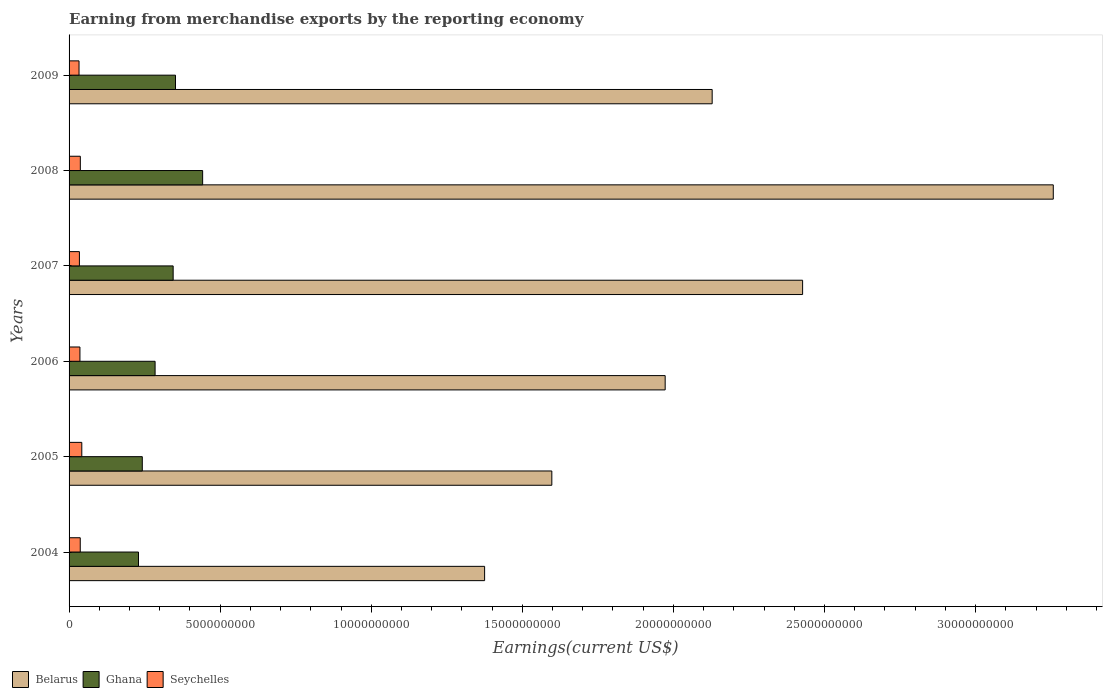Are the number of bars per tick equal to the number of legend labels?
Your response must be concise. Yes. Are the number of bars on each tick of the Y-axis equal?
Your answer should be very brief. Yes. What is the label of the 3rd group of bars from the top?
Your response must be concise. 2007. In how many cases, is the number of bars for a given year not equal to the number of legend labels?
Offer a very short reply. 0. What is the amount earned from merchandise exports in Ghana in 2004?
Your answer should be very brief. 2.30e+09. Across all years, what is the maximum amount earned from merchandise exports in Belarus?
Offer a terse response. 3.26e+1. Across all years, what is the minimum amount earned from merchandise exports in Seychelles?
Keep it short and to the point. 3.30e+08. What is the total amount earned from merchandise exports in Ghana in the graph?
Your response must be concise. 1.90e+1. What is the difference between the amount earned from merchandise exports in Belarus in 2004 and that in 2008?
Make the answer very short. -1.88e+1. What is the difference between the amount earned from merchandise exports in Ghana in 2006 and the amount earned from merchandise exports in Seychelles in 2009?
Your response must be concise. 2.52e+09. What is the average amount earned from merchandise exports in Ghana per year?
Your response must be concise. 3.16e+09. In the year 2007, what is the difference between the amount earned from merchandise exports in Seychelles and amount earned from merchandise exports in Belarus?
Provide a succinct answer. -2.39e+1. In how many years, is the amount earned from merchandise exports in Belarus greater than 3000000000 US$?
Provide a short and direct response. 6. What is the ratio of the amount earned from merchandise exports in Belarus in 2004 to that in 2005?
Your answer should be very brief. 0.86. Is the amount earned from merchandise exports in Seychelles in 2006 less than that in 2007?
Make the answer very short. No. What is the difference between the highest and the second highest amount earned from merchandise exports in Seychelles?
Your response must be concise. 4.87e+07. What is the difference between the highest and the lowest amount earned from merchandise exports in Seychelles?
Your answer should be very brief. 9.14e+07. Is the sum of the amount earned from merchandise exports in Ghana in 2005 and 2008 greater than the maximum amount earned from merchandise exports in Belarus across all years?
Provide a short and direct response. No. What does the 2nd bar from the top in 2008 represents?
Your response must be concise. Ghana. What does the 1st bar from the bottom in 2005 represents?
Offer a terse response. Belarus. How many years are there in the graph?
Make the answer very short. 6. What is the difference between two consecutive major ticks on the X-axis?
Make the answer very short. 5.00e+09. Does the graph contain any zero values?
Your answer should be compact. No. Does the graph contain grids?
Offer a very short reply. No. Where does the legend appear in the graph?
Provide a succinct answer. Bottom left. What is the title of the graph?
Give a very brief answer. Earning from merchandise exports by the reporting economy. What is the label or title of the X-axis?
Your answer should be compact. Earnings(current US$). What is the label or title of the Y-axis?
Provide a succinct answer. Years. What is the Earnings(current US$) of Belarus in 2004?
Offer a very short reply. 1.38e+1. What is the Earnings(current US$) of Ghana in 2004?
Provide a succinct answer. 2.30e+09. What is the Earnings(current US$) of Seychelles in 2004?
Your response must be concise. 3.70e+08. What is the Earnings(current US$) of Belarus in 2005?
Give a very brief answer. 1.60e+1. What is the Earnings(current US$) in Ghana in 2005?
Your answer should be very brief. 2.42e+09. What is the Earnings(current US$) of Seychelles in 2005?
Your answer should be very brief. 4.21e+08. What is the Earnings(current US$) in Belarus in 2006?
Provide a succinct answer. 1.97e+1. What is the Earnings(current US$) in Ghana in 2006?
Provide a short and direct response. 2.85e+09. What is the Earnings(current US$) of Seychelles in 2006?
Offer a terse response. 3.60e+08. What is the Earnings(current US$) of Belarus in 2007?
Provide a short and direct response. 2.43e+1. What is the Earnings(current US$) in Ghana in 2007?
Offer a very short reply. 3.44e+09. What is the Earnings(current US$) in Seychelles in 2007?
Keep it short and to the point. 3.42e+08. What is the Earnings(current US$) in Belarus in 2008?
Make the answer very short. 3.26e+1. What is the Earnings(current US$) in Ghana in 2008?
Keep it short and to the point. 4.42e+09. What is the Earnings(current US$) of Seychelles in 2008?
Your answer should be very brief. 3.72e+08. What is the Earnings(current US$) in Belarus in 2009?
Your answer should be very brief. 2.13e+1. What is the Earnings(current US$) of Ghana in 2009?
Offer a very short reply. 3.52e+09. What is the Earnings(current US$) in Seychelles in 2009?
Give a very brief answer. 3.30e+08. Across all years, what is the maximum Earnings(current US$) of Belarus?
Offer a terse response. 3.26e+1. Across all years, what is the maximum Earnings(current US$) of Ghana?
Provide a short and direct response. 4.42e+09. Across all years, what is the maximum Earnings(current US$) in Seychelles?
Provide a succinct answer. 4.21e+08. Across all years, what is the minimum Earnings(current US$) in Belarus?
Ensure brevity in your answer.  1.38e+1. Across all years, what is the minimum Earnings(current US$) of Ghana?
Make the answer very short. 2.30e+09. Across all years, what is the minimum Earnings(current US$) in Seychelles?
Your answer should be very brief. 3.30e+08. What is the total Earnings(current US$) of Belarus in the graph?
Your answer should be very brief. 1.28e+11. What is the total Earnings(current US$) in Ghana in the graph?
Your answer should be compact. 1.90e+1. What is the total Earnings(current US$) of Seychelles in the graph?
Your response must be concise. 2.19e+09. What is the difference between the Earnings(current US$) in Belarus in 2004 and that in 2005?
Provide a succinct answer. -2.22e+09. What is the difference between the Earnings(current US$) of Ghana in 2004 and that in 2005?
Provide a succinct answer. -1.26e+08. What is the difference between the Earnings(current US$) of Seychelles in 2004 and that in 2005?
Keep it short and to the point. -5.12e+07. What is the difference between the Earnings(current US$) in Belarus in 2004 and that in 2006?
Your answer should be very brief. -5.98e+09. What is the difference between the Earnings(current US$) in Ghana in 2004 and that in 2006?
Offer a very short reply. -5.49e+08. What is the difference between the Earnings(current US$) in Seychelles in 2004 and that in 2006?
Provide a short and direct response. 1.00e+07. What is the difference between the Earnings(current US$) in Belarus in 2004 and that in 2007?
Offer a terse response. -1.05e+1. What is the difference between the Earnings(current US$) in Ghana in 2004 and that in 2007?
Offer a terse response. -1.15e+09. What is the difference between the Earnings(current US$) of Seychelles in 2004 and that in 2007?
Your answer should be compact. 2.79e+07. What is the difference between the Earnings(current US$) in Belarus in 2004 and that in 2008?
Ensure brevity in your answer.  -1.88e+1. What is the difference between the Earnings(current US$) in Ghana in 2004 and that in 2008?
Your answer should be very brief. -2.12e+09. What is the difference between the Earnings(current US$) of Seychelles in 2004 and that in 2008?
Ensure brevity in your answer.  -2.53e+06. What is the difference between the Earnings(current US$) in Belarus in 2004 and that in 2009?
Your answer should be very brief. -7.53e+09. What is the difference between the Earnings(current US$) of Ghana in 2004 and that in 2009?
Your answer should be very brief. -1.22e+09. What is the difference between the Earnings(current US$) in Seychelles in 2004 and that in 2009?
Offer a very short reply. 4.02e+07. What is the difference between the Earnings(current US$) in Belarus in 2005 and that in 2006?
Ensure brevity in your answer.  -3.75e+09. What is the difference between the Earnings(current US$) in Ghana in 2005 and that in 2006?
Your answer should be compact. -4.24e+08. What is the difference between the Earnings(current US$) of Seychelles in 2005 and that in 2006?
Make the answer very short. 6.12e+07. What is the difference between the Earnings(current US$) in Belarus in 2005 and that in 2007?
Your answer should be very brief. -8.30e+09. What is the difference between the Earnings(current US$) in Ghana in 2005 and that in 2007?
Your response must be concise. -1.02e+09. What is the difference between the Earnings(current US$) in Seychelles in 2005 and that in 2007?
Provide a succinct answer. 7.91e+07. What is the difference between the Earnings(current US$) of Belarus in 2005 and that in 2008?
Your answer should be very brief. -1.66e+1. What is the difference between the Earnings(current US$) in Ghana in 2005 and that in 2008?
Your answer should be very brief. -2.00e+09. What is the difference between the Earnings(current US$) in Seychelles in 2005 and that in 2008?
Give a very brief answer. 4.87e+07. What is the difference between the Earnings(current US$) of Belarus in 2005 and that in 2009?
Provide a succinct answer. -5.31e+09. What is the difference between the Earnings(current US$) in Ghana in 2005 and that in 2009?
Your response must be concise. -1.10e+09. What is the difference between the Earnings(current US$) of Seychelles in 2005 and that in 2009?
Offer a terse response. 9.14e+07. What is the difference between the Earnings(current US$) of Belarus in 2006 and that in 2007?
Your response must be concise. -4.55e+09. What is the difference between the Earnings(current US$) in Ghana in 2006 and that in 2007?
Make the answer very short. -5.98e+08. What is the difference between the Earnings(current US$) in Seychelles in 2006 and that in 2007?
Your answer should be compact. 1.78e+07. What is the difference between the Earnings(current US$) in Belarus in 2006 and that in 2008?
Ensure brevity in your answer.  -1.28e+1. What is the difference between the Earnings(current US$) of Ghana in 2006 and that in 2008?
Your answer should be compact. -1.57e+09. What is the difference between the Earnings(current US$) in Seychelles in 2006 and that in 2008?
Offer a terse response. -1.26e+07. What is the difference between the Earnings(current US$) of Belarus in 2006 and that in 2009?
Ensure brevity in your answer.  -1.56e+09. What is the difference between the Earnings(current US$) in Ghana in 2006 and that in 2009?
Offer a terse response. -6.75e+08. What is the difference between the Earnings(current US$) of Seychelles in 2006 and that in 2009?
Provide a short and direct response. 3.01e+07. What is the difference between the Earnings(current US$) in Belarus in 2007 and that in 2008?
Offer a very short reply. -8.30e+09. What is the difference between the Earnings(current US$) in Ghana in 2007 and that in 2008?
Your answer should be very brief. -9.76e+08. What is the difference between the Earnings(current US$) in Seychelles in 2007 and that in 2008?
Provide a succinct answer. -3.04e+07. What is the difference between the Earnings(current US$) in Belarus in 2007 and that in 2009?
Give a very brief answer. 2.99e+09. What is the difference between the Earnings(current US$) of Ghana in 2007 and that in 2009?
Offer a very short reply. -7.73e+07. What is the difference between the Earnings(current US$) in Seychelles in 2007 and that in 2009?
Keep it short and to the point. 1.23e+07. What is the difference between the Earnings(current US$) of Belarus in 2008 and that in 2009?
Your answer should be compact. 1.13e+1. What is the difference between the Earnings(current US$) of Ghana in 2008 and that in 2009?
Ensure brevity in your answer.  8.98e+08. What is the difference between the Earnings(current US$) in Seychelles in 2008 and that in 2009?
Your response must be concise. 4.27e+07. What is the difference between the Earnings(current US$) of Belarus in 2004 and the Earnings(current US$) of Ghana in 2005?
Your answer should be compact. 1.13e+1. What is the difference between the Earnings(current US$) in Belarus in 2004 and the Earnings(current US$) in Seychelles in 2005?
Offer a very short reply. 1.33e+1. What is the difference between the Earnings(current US$) of Ghana in 2004 and the Earnings(current US$) of Seychelles in 2005?
Make the answer very short. 1.88e+09. What is the difference between the Earnings(current US$) in Belarus in 2004 and the Earnings(current US$) in Ghana in 2006?
Make the answer very short. 1.09e+1. What is the difference between the Earnings(current US$) in Belarus in 2004 and the Earnings(current US$) in Seychelles in 2006?
Give a very brief answer. 1.34e+1. What is the difference between the Earnings(current US$) in Ghana in 2004 and the Earnings(current US$) in Seychelles in 2006?
Provide a short and direct response. 1.94e+09. What is the difference between the Earnings(current US$) of Belarus in 2004 and the Earnings(current US$) of Ghana in 2007?
Keep it short and to the point. 1.03e+1. What is the difference between the Earnings(current US$) of Belarus in 2004 and the Earnings(current US$) of Seychelles in 2007?
Your answer should be very brief. 1.34e+1. What is the difference between the Earnings(current US$) in Ghana in 2004 and the Earnings(current US$) in Seychelles in 2007?
Ensure brevity in your answer.  1.96e+09. What is the difference between the Earnings(current US$) of Belarus in 2004 and the Earnings(current US$) of Ghana in 2008?
Make the answer very short. 9.33e+09. What is the difference between the Earnings(current US$) in Belarus in 2004 and the Earnings(current US$) in Seychelles in 2008?
Keep it short and to the point. 1.34e+1. What is the difference between the Earnings(current US$) in Ghana in 2004 and the Earnings(current US$) in Seychelles in 2008?
Give a very brief answer. 1.93e+09. What is the difference between the Earnings(current US$) of Belarus in 2004 and the Earnings(current US$) of Ghana in 2009?
Your answer should be very brief. 1.02e+1. What is the difference between the Earnings(current US$) of Belarus in 2004 and the Earnings(current US$) of Seychelles in 2009?
Provide a short and direct response. 1.34e+1. What is the difference between the Earnings(current US$) of Ghana in 2004 and the Earnings(current US$) of Seychelles in 2009?
Ensure brevity in your answer.  1.97e+09. What is the difference between the Earnings(current US$) in Belarus in 2005 and the Earnings(current US$) in Ghana in 2006?
Your answer should be very brief. 1.31e+1. What is the difference between the Earnings(current US$) in Belarus in 2005 and the Earnings(current US$) in Seychelles in 2006?
Your answer should be compact. 1.56e+1. What is the difference between the Earnings(current US$) of Ghana in 2005 and the Earnings(current US$) of Seychelles in 2006?
Offer a terse response. 2.06e+09. What is the difference between the Earnings(current US$) in Belarus in 2005 and the Earnings(current US$) in Ghana in 2007?
Your answer should be very brief. 1.25e+1. What is the difference between the Earnings(current US$) in Belarus in 2005 and the Earnings(current US$) in Seychelles in 2007?
Give a very brief answer. 1.56e+1. What is the difference between the Earnings(current US$) in Ghana in 2005 and the Earnings(current US$) in Seychelles in 2007?
Your response must be concise. 2.08e+09. What is the difference between the Earnings(current US$) in Belarus in 2005 and the Earnings(current US$) in Ghana in 2008?
Offer a very short reply. 1.16e+1. What is the difference between the Earnings(current US$) of Belarus in 2005 and the Earnings(current US$) of Seychelles in 2008?
Ensure brevity in your answer.  1.56e+1. What is the difference between the Earnings(current US$) of Ghana in 2005 and the Earnings(current US$) of Seychelles in 2008?
Your response must be concise. 2.05e+09. What is the difference between the Earnings(current US$) in Belarus in 2005 and the Earnings(current US$) in Ghana in 2009?
Your answer should be compact. 1.25e+1. What is the difference between the Earnings(current US$) of Belarus in 2005 and the Earnings(current US$) of Seychelles in 2009?
Keep it short and to the point. 1.56e+1. What is the difference between the Earnings(current US$) in Ghana in 2005 and the Earnings(current US$) in Seychelles in 2009?
Give a very brief answer. 2.09e+09. What is the difference between the Earnings(current US$) of Belarus in 2006 and the Earnings(current US$) of Ghana in 2007?
Offer a very short reply. 1.63e+1. What is the difference between the Earnings(current US$) of Belarus in 2006 and the Earnings(current US$) of Seychelles in 2007?
Your response must be concise. 1.94e+1. What is the difference between the Earnings(current US$) of Ghana in 2006 and the Earnings(current US$) of Seychelles in 2007?
Offer a terse response. 2.51e+09. What is the difference between the Earnings(current US$) in Belarus in 2006 and the Earnings(current US$) in Ghana in 2008?
Provide a succinct answer. 1.53e+1. What is the difference between the Earnings(current US$) in Belarus in 2006 and the Earnings(current US$) in Seychelles in 2008?
Offer a very short reply. 1.94e+1. What is the difference between the Earnings(current US$) in Ghana in 2006 and the Earnings(current US$) in Seychelles in 2008?
Provide a succinct answer. 2.47e+09. What is the difference between the Earnings(current US$) of Belarus in 2006 and the Earnings(current US$) of Ghana in 2009?
Make the answer very short. 1.62e+1. What is the difference between the Earnings(current US$) in Belarus in 2006 and the Earnings(current US$) in Seychelles in 2009?
Your response must be concise. 1.94e+1. What is the difference between the Earnings(current US$) of Ghana in 2006 and the Earnings(current US$) of Seychelles in 2009?
Your answer should be very brief. 2.52e+09. What is the difference between the Earnings(current US$) in Belarus in 2007 and the Earnings(current US$) in Ghana in 2008?
Keep it short and to the point. 1.99e+1. What is the difference between the Earnings(current US$) of Belarus in 2007 and the Earnings(current US$) of Seychelles in 2008?
Give a very brief answer. 2.39e+1. What is the difference between the Earnings(current US$) in Ghana in 2007 and the Earnings(current US$) in Seychelles in 2008?
Give a very brief answer. 3.07e+09. What is the difference between the Earnings(current US$) of Belarus in 2007 and the Earnings(current US$) of Ghana in 2009?
Offer a terse response. 2.08e+1. What is the difference between the Earnings(current US$) of Belarus in 2007 and the Earnings(current US$) of Seychelles in 2009?
Your answer should be compact. 2.39e+1. What is the difference between the Earnings(current US$) of Ghana in 2007 and the Earnings(current US$) of Seychelles in 2009?
Keep it short and to the point. 3.12e+09. What is the difference between the Earnings(current US$) in Belarus in 2008 and the Earnings(current US$) in Ghana in 2009?
Your response must be concise. 2.90e+1. What is the difference between the Earnings(current US$) of Belarus in 2008 and the Earnings(current US$) of Seychelles in 2009?
Provide a short and direct response. 3.22e+1. What is the difference between the Earnings(current US$) of Ghana in 2008 and the Earnings(current US$) of Seychelles in 2009?
Offer a terse response. 4.09e+09. What is the average Earnings(current US$) of Belarus per year?
Your answer should be compact. 2.13e+1. What is the average Earnings(current US$) in Ghana per year?
Provide a short and direct response. 3.16e+09. What is the average Earnings(current US$) of Seychelles per year?
Keep it short and to the point. 3.66e+08. In the year 2004, what is the difference between the Earnings(current US$) in Belarus and Earnings(current US$) in Ghana?
Ensure brevity in your answer.  1.15e+1. In the year 2004, what is the difference between the Earnings(current US$) in Belarus and Earnings(current US$) in Seychelles?
Make the answer very short. 1.34e+1. In the year 2004, what is the difference between the Earnings(current US$) in Ghana and Earnings(current US$) in Seychelles?
Offer a very short reply. 1.93e+09. In the year 2005, what is the difference between the Earnings(current US$) of Belarus and Earnings(current US$) of Ghana?
Make the answer very short. 1.36e+1. In the year 2005, what is the difference between the Earnings(current US$) of Belarus and Earnings(current US$) of Seychelles?
Ensure brevity in your answer.  1.56e+1. In the year 2005, what is the difference between the Earnings(current US$) of Ghana and Earnings(current US$) of Seychelles?
Ensure brevity in your answer.  2.00e+09. In the year 2006, what is the difference between the Earnings(current US$) of Belarus and Earnings(current US$) of Ghana?
Keep it short and to the point. 1.69e+1. In the year 2006, what is the difference between the Earnings(current US$) of Belarus and Earnings(current US$) of Seychelles?
Your answer should be very brief. 1.94e+1. In the year 2006, what is the difference between the Earnings(current US$) in Ghana and Earnings(current US$) in Seychelles?
Provide a short and direct response. 2.49e+09. In the year 2007, what is the difference between the Earnings(current US$) of Belarus and Earnings(current US$) of Ghana?
Offer a very short reply. 2.08e+1. In the year 2007, what is the difference between the Earnings(current US$) of Belarus and Earnings(current US$) of Seychelles?
Offer a terse response. 2.39e+1. In the year 2007, what is the difference between the Earnings(current US$) in Ghana and Earnings(current US$) in Seychelles?
Provide a succinct answer. 3.10e+09. In the year 2008, what is the difference between the Earnings(current US$) of Belarus and Earnings(current US$) of Ghana?
Your response must be concise. 2.82e+1. In the year 2008, what is the difference between the Earnings(current US$) in Belarus and Earnings(current US$) in Seychelles?
Provide a succinct answer. 3.22e+1. In the year 2008, what is the difference between the Earnings(current US$) of Ghana and Earnings(current US$) of Seychelles?
Offer a very short reply. 4.05e+09. In the year 2009, what is the difference between the Earnings(current US$) of Belarus and Earnings(current US$) of Ghana?
Offer a terse response. 1.78e+1. In the year 2009, what is the difference between the Earnings(current US$) in Belarus and Earnings(current US$) in Seychelles?
Provide a short and direct response. 2.10e+1. In the year 2009, what is the difference between the Earnings(current US$) in Ghana and Earnings(current US$) in Seychelles?
Your response must be concise. 3.19e+09. What is the ratio of the Earnings(current US$) of Belarus in 2004 to that in 2005?
Give a very brief answer. 0.86. What is the ratio of the Earnings(current US$) in Ghana in 2004 to that in 2005?
Ensure brevity in your answer.  0.95. What is the ratio of the Earnings(current US$) of Seychelles in 2004 to that in 2005?
Offer a very short reply. 0.88. What is the ratio of the Earnings(current US$) in Belarus in 2004 to that in 2006?
Give a very brief answer. 0.7. What is the ratio of the Earnings(current US$) in Ghana in 2004 to that in 2006?
Offer a terse response. 0.81. What is the ratio of the Earnings(current US$) of Seychelles in 2004 to that in 2006?
Provide a short and direct response. 1.03. What is the ratio of the Earnings(current US$) in Belarus in 2004 to that in 2007?
Your answer should be very brief. 0.57. What is the ratio of the Earnings(current US$) in Ghana in 2004 to that in 2007?
Ensure brevity in your answer.  0.67. What is the ratio of the Earnings(current US$) in Seychelles in 2004 to that in 2007?
Keep it short and to the point. 1.08. What is the ratio of the Earnings(current US$) in Belarus in 2004 to that in 2008?
Offer a terse response. 0.42. What is the ratio of the Earnings(current US$) in Ghana in 2004 to that in 2008?
Your answer should be very brief. 0.52. What is the ratio of the Earnings(current US$) in Seychelles in 2004 to that in 2008?
Offer a terse response. 0.99. What is the ratio of the Earnings(current US$) in Belarus in 2004 to that in 2009?
Offer a terse response. 0.65. What is the ratio of the Earnings(current US$) in Ghana in 2004 to that in 2009?
Provide a short and direct response. 0.65. What is the ratio of the Earnings(current US$) of Seychelles in 2004 to that in 2009?
Your answer should be compact. 1.12. What is the ratio of the Earnings(current US$) of Belarus in 2005 to that in 2006?
Your answer should be compact. 0.81. What is the ratio of the Earnings(current US$) of Ghana in 2005 to that in 2006?
Make the answer very short. 0.85. What is the ratio of the Earnings(current US$) of Seychelles in 2005 to that in 2006?
Provide a succinct answer. 1.17. What is the ratio of the Earnings(current US$) in Belarus in 2005 to that in 2007?
Your answer should be compact. 0.66. What is the ratio of the Earnings(current US$) in Ghana in 2005 to that in 2007?
Give a very brief answer. 0.7. What is the ratio of the Earnings(current US$) of Seychelles in 2005 to that in 2007?
Your response must be concise. 1.23. What is the ratio of the Earnings(current US$) in Belarus in 2005 to that in 2008?
Your answer should be very brief. 0.49. What is the ratio of the Earnings(current US$) in Ghana in 2005 to that in 2008?
Offer a very short reply. 0.55. What is the ratio of the Earnings(current US$) in Seychelles in 2005 to that in 2008?
Ensure brevity in your answer.  1.13. What is the ratio of the Earnings(current US$) of Belarus in 2005 to that in 2009?
Keep it short and to the point. 0.75. What is the ratio of the Earnings(current US$) of Ghana in 2005 to that in 2009?
Provide a succinct answer. 0.69. What is the ratio of the Earnings(current US$) in Seychelles in 2005 to that in 2009?
Give a very brief answer. 1.28. What is the ratio of the Earnings(current US$) of Belarus in 2006 to that in 2007?
Provide a short and direct response. 0.81. What is the ratio of the Earnings(current US$) in Ghana in 2006 to that in 2007?
Your answer should be compact. 0.83. What is the ratio of the Earnings(current US$) of Seychelles in 2006 to that in 2007?
Ensure brevity in your answer.  1.05. What is the ratio of the Earnings(current US$) in Belarus in 2006 to that in 2008?
Keep it short and to the point. 0.61. What is the ratio of the Earnings(current US$) of Ghana in 2006 to that in 2008?
Provide a succinct answer. 0.64. What is the ratio of the Earnings(current US$) in Seychelles in 2006 to that in 2008?
Keep it short and to the point. 0.97. What is the ratio of the Earnings(current US$) of Belarus in 2006 to that in 2009?
Your answer should be compact. 0.93. What is the ratio of the Earnings(current US$) of Ghana in 2006 to that in 2009?
Keep it short and to the point. 0.81. What is the ratio of the Earnings(current US$) of Seychelles in 2006 to that in 2009?
Provide a succinct answer. 1.09. What is the ratio of the Earnings(current US$) in Belarus in 2007 to that in 2008?
Your response must be concise. 0.75. What is the ratio of the Earnings(current US$) of Ghana in 2007 to that in 2008?
Your response must be concise. 0.78. What is the ratio of the Earnings(current US$) of Seychelles in 2007 to that in 2008?
Make the answer very short. 0.92. What is the ratio of the Earnings(current US$) in Belarus in 2007 to that in 2009?
Ensure brevity in your answer.  1.14. What is the ratio of the Earnings(current US$) in Ghana in 2007 to that in 2009?
Provide a short and direct response. 0.98. What is the ratio of the Earnings(current US$) of Seychelles in 2007 to that in 2009?
Your response must be concise. 1.04. What is the ratio of the Earnings(current US$) of Belarus in 2008 to that in 2009?
Offer a terse response. 1.53. What is the ratio of the Earnings(current US$) of Ghana in 2008 to that in 2009?
Ensure brevity in your answer.  1.26. What is the ratio of the Earnings(current US$) of Seychelles in 2008 to that in 2009?
Offer a terse response. 1.13. What is the difference between the highest and the second highest Earnings(current US$) in Belarus?
Your answer should be compact. 8.30e+09. What is the difference between the highest and the second highest Earnings(current US$) of Ghana?
Keep it short and to the point. 8.98e+08. What is the difference between the highest and the second highest Earnings(current US$) in Seychelles?
Offer a very short reply. 4.87e+07. What is the difference between the highest and the lowest Earnings(current US$) in Belarus?
Keep it short and to the point. 1.88e+1. What is the difference between the highest and the lowest Earnings(current US$) of Ghana?
Offer a very short reply. 2.12e+09. What is the difference between the highest and the lowest Earnings(current US$) of Seychelles?
Your answer should be very brief. 9.14e+07. 